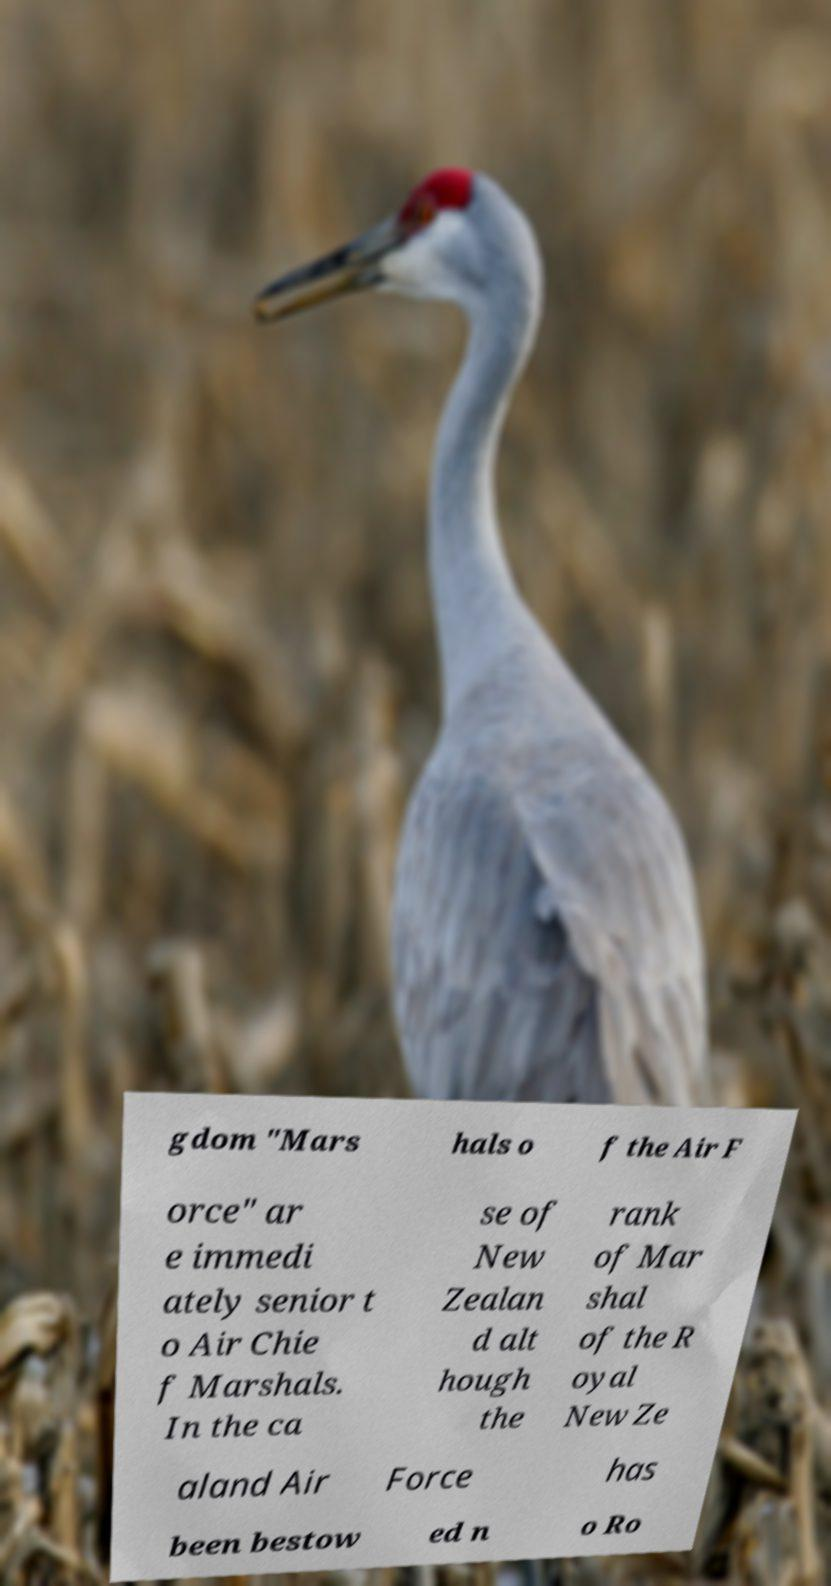Can you read and provide the text displayed in the image?This photo seems to have some interesting text. Can you extract and type it out for me? gdom "Mars hals o f the Air F orce" ar e immedi ately senior t o Air Chie f Marshals. In the ca se of New Zealan d alt hough the rank of Mar shal of the R oyal New Ze aland Air Force has been bestow ed n o Ro 